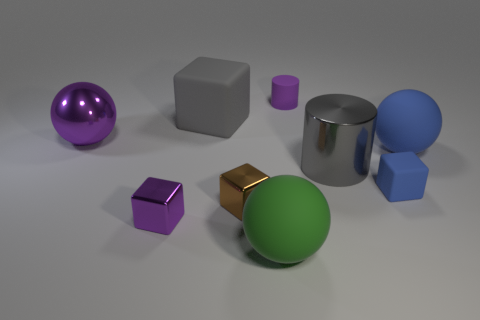Do the tiny purple rubber thing and the purple object in front of the large purple metallic thing have the same shape? No, the tiny purple object appears to be a small cylinder, while the purple object in front of the large metallic sphere is a cube. Although they share a similar color, their shapes are quite distinct; the cube has six faces with edges of equal length meeting at right angles, and the small cylinder has a circular top and bottom with a curved side. 